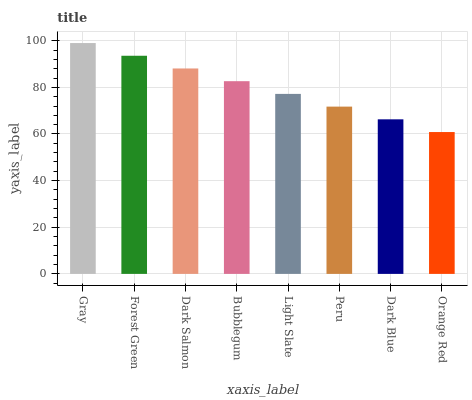Is Orange Red the minimum?
Answer yes or no. Yes. Is Gray the maximum?
Answer yes or no. Yes. Is Forest Green the minimum?
Answer yes or no. No. Is Forest Green the maximum?
Answer yes or no. No. Is Gray greater than Forest Green?
Answer yes or no. Yes. Is Forest Green less than Gray?
Answer yes or no. Yes. Is Forest Green greater than Gray?
Answer yes or no. No. Is Gray less than Forest Green?
Answer yes or no. No. Is Bubblegum the high median?
Answer yes or no. Yes. Is Light Slate the low median?
Answer yes or no. Yes. Is Peru the high median?
Answer yes or no. No. Is Dark Salmon the low median?
Answer yes or no. No. 